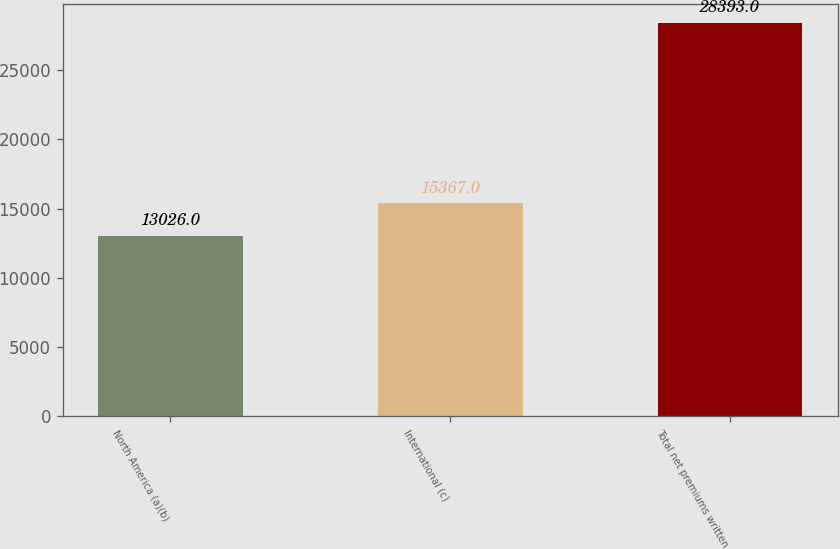Convert chart to OTSL. <chart><loc_0><loc_0><loc_500><loc_500><bar_chart><fcel>North America (a)(b)<fcel>International (c)<fcel>Total net premiums written<nl><fcel>13026<fcel>15367<fcel>28393<nl></chart> 